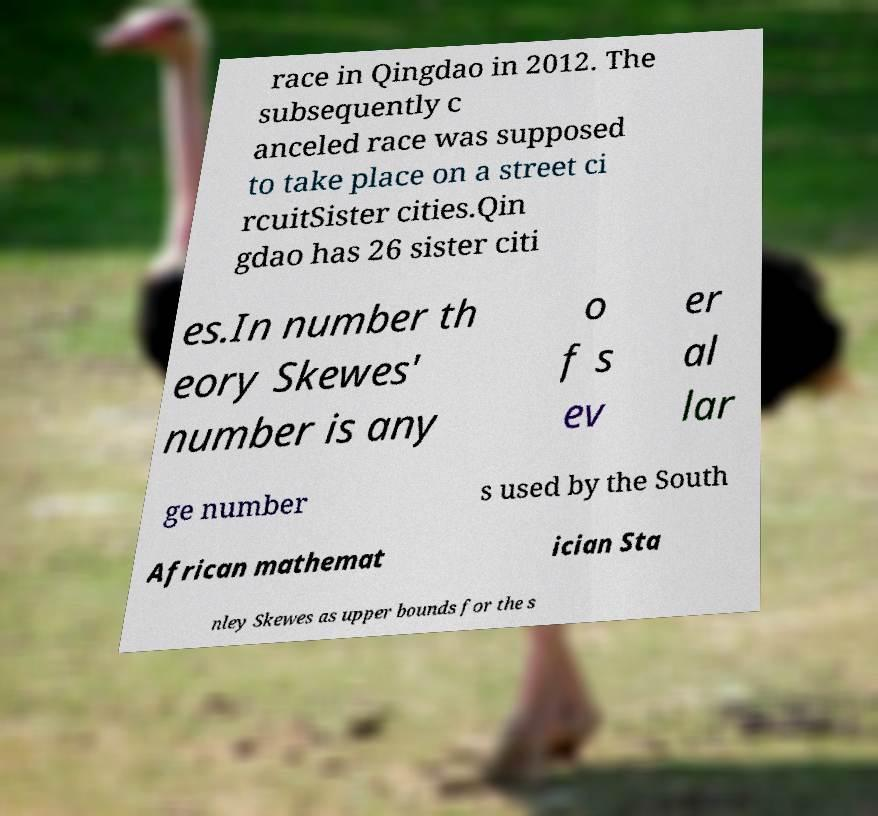Can you accurately transcribe the text from the provided image for me? race in Qingdao in 2012. The subsequently c anceled race was supposed to take place on a street ci rcuitSister cities.Qin gdao has 26 sister citi es.In number th eory Skewes' number is any o f s ev er al lar ge number s used by the South African mathemat ician Sta nley Skewes as upper bounds for the s 